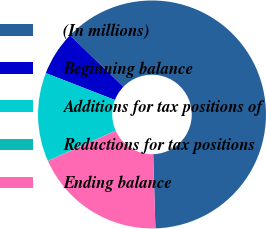Convert chart to OTSL. <chart><loc_0><loc_0><loc_500><loc_500><pie_chart><fcel>(In millions)<fcel>Beginning balance<fcel>Additions for tax positions of<fcel>Reductions for tax positions<fcel>Ending balance<nl><fcel>62.3%<fcel>6.31%<fcel>12.53%<fcel>0.09%<fcel>18.76%<nl></chart> 